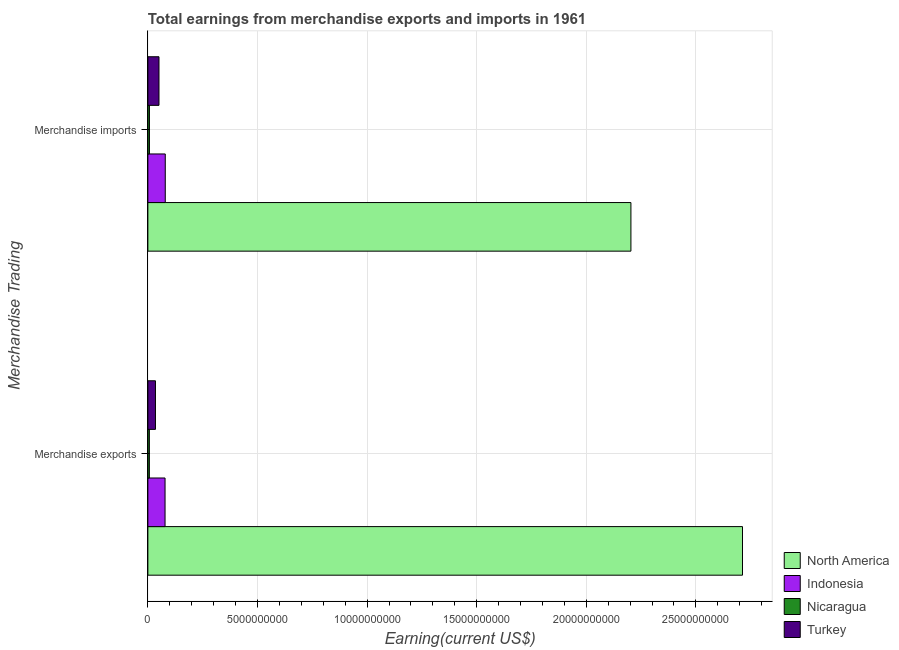How many groups of bars are there?
Ensure brevity in your answer.  2. Are the number of bars per tick equal to the number of legend labels?
Give a very brief answer. Yes. What is the label of the 2nd group of bars from the top?
Your answer should be very brief. Merchandise exports. What is the earnings from merchandise imports in Turkey?
Offer a very short reply. 5.07e+08. Across all countries, what is the maximum earnings from merchandise imports?
Provide a short and direct response. 2.20e+1. Across all countries, what is the minimum earnings from merchandise imports?
Provide a short and direct response. 7.15e+07. In which country was the earnings from merchandise exports maximum?
Offer a terse response. North America. In which country was the earnings from merchandise exports minimum?
Make the answer very short. Nicaragua. What is the total earnings from merchandise exports in the graph?
Give a very brief answer. 2.83e+1. What is the difference between the earnings from merchandise imports in North America and that in Turkey?
Offer a terse response. 2.15e+1. What is the difference between the earnings from merchandise imports in Nicaragua and the earnings from merchandise exports in Indonesia?
Provide a succinct answer. -7.13e+08. What is the average earnings from merchandise imports per country?
Give a very brief answer. 5.85e+09. What is the difference between the earnings from merchandise imports and earnings from merchandise exports in Turkey?
Provide a short and direct response. 1.60e+08. In how many countries, is the earnings from merchandise exports greater than 2000000000 US$?
Make the answer very short. 1. What is the ratio of the earnings from merchandise exports in Turkey to that in Indonesia?
Give a very brief answer. 0.44. Is the earnings from merchandise exports in Turkey less than that in Indonesia?
Keep it short and to the point. Yes. In how many countries, is the earnings from merchandise exports greater than the average earnings from merchandise exports taken over all countries?
Ensure brevity in your answer.  1. What does the 3rd bar from the top in Merchandise exports represents?
Your answer should be very brief. Indonesia. What does the 3rd bar from the bottom in Merchandise imports represents?
Your answer should be compact. Nicaragua. How many bars are there?
Keep it short and to the point. 8. Are all the bars in the graph horizontal?
Offer a very short reply. Yes. What is the difference between two consecutive major ticks on the X-axis?
Make the answer very short. 5.00e+09. Does the graph contain grids?
Your answer should be very brief. Yes. Where does the legend appear in the graph?
Offer a very short reply. Bottom right. What is the title of the graph?
Keep it short and to the point. Total earnings from merchandise exports and imports in 1961. Does "Oman" appear as one of the legend labels in the graph?
Offer a very short reply. No. What is the label or title of the X-axis?
Your answer should be very brief. Earning(current US$). What is the label or title of the Y-axis?
Your answer should be compact. Merchandise Trading. What is the Earning(current US$) of North America in Merchandise exports?
Offer a terse response. 2.71e+1. What is the Earning(current US$) in Indonesia in Merchandise exports?
Provide a short and direct response. 7.84e+08. What is the Earning(current US$) of Nicaragua in Merchandise exports?
Your response must be concise. 6.84e+07. What is the Earning(current US$) in Turkey in Merchandise exports?
Your answer should be very brief. 3.47e+08. What is the Earning(current US$) in North America in Merchandise imports?
Provide a succinct answer. 2.20e+1. What is the Earning(current US$) of Indonesia in Merchandise imports?
Offer a terse response. 7.94e+08. What is the Earning(current US$) of Nicaragua in Merchandise imports?
Your answer should be compact. 7.15e+07. What is the Earning(current US$) of Turkey in Merchandise imports?
Your response must be concise. 5.07e+08. Across all Merchandise Trading, what is the maximum Earning(current US$) of North America?
Offer a terse response. 2.71e+1. Across all Merchandise Trading, what is the maximum Earning(current US$) in Indonesia?
Provide a succinct answer. 7.94e+08. Across all Merchandise Trading, what is the maximum Earning(current US$) in Nicaragua?
Provide a short and direct response. 7.15e+07. Across all Merchandise Trading, what is the maximum Earning(current US$) of Turkey?
Keep it short and to the point. 5.07e+08. Across all Merchandise Trading, what is the minimum Earning(current US$) of North America?
Your answer should be very brief. 2.20e+1. Across all Merchandise Trading, what is the minimum Earning(current US$) of Indonesia?
Provide a succinct answer. 7.84e+08. Across all Merchandise Trading, what is the minimum Earning(current US$) in Nicaragua?
Offer a terse response. 6.84e+07. Across all Merchandise Trading, what is the minimum Earning(current US$) in Turkey?
Your answer should be compact. 3.47e+08. What is the total Earning(current US$) in North America in the graph?
Ensure brevity in your answer.  4.92e+1. What is the total Earning(current US$) of Indonesia in the graph?
Provide a short and direct response. 1.58e+09. What is the total Earning(current US$) in Nicaragua in the graph?
Make the answer very short. 1.40e+08. What is the total Earning(current US$) of Turkey in the graph?
Give a very brief answer. 8.54e+08. What is the difference between the Earning(current US$) of North America in Merchandise exports and that in Merchandise imports?
Provide a short and direct response. 5.09e+09. What is the difference between the Earning(current US$) of Indonesia in Merchandise exports and that in Merchandise imports?
Your answer should be compact. -1.00e+07. What is the difference between the Earning(current US$) in Nicaragua in Merchandise exports and that in Merchandise imports?
Your answer should be compact. -3.11e+06. What is the difference between the Earning(current US$) in Turkey in Merchandise exports and that in Merchandise imports?
Ensure brevity in your answer.  -1.60e+08. What is the difference between the Earning(current US$) of North America in Merchandise exports and the Earning(current US$) of Indonesia in Merchandise imports?
Keep it short and to the point. 2.63e+1. What is the difference between the Earning(current US$) in North America in Merchandise exports and the Earning(current US$) in Nicaragua in Merchandise imports?
Offer a terse response. 2.71e+1. What is the difference between the Earning(current US$) of North America in Merchandise exports and the Earning(current US$) of Turkey in Merchandise imports?
Your answer should be compact. 2.66e+1. What is the difference between the Earning(current US$) of Indonesia in Merchandise exports and the Earning(current US$) of Nicaragua in Merchandise imports?
Provide a short and direct response. 7.13e+08. What is the difference between the Earning(current US$) in Indonesia in Merchandise exports and the Earning(current US$) in Turkey in Merchandise imports?
Your answer should be compact. 2.77e+08. What is the difference between the Earning(current US$) in Nicaragua in Merchandise exports and the Earning(current US$) in Turkey in Merchandise imports?
Your response must be concise. -4.39e+08. What is the average Earning(current US$) of North America per Merchandise Trading?
Offer a terse response. 2.46e+1. What is the average Earning(current US$) in Indonesia per Merchandise Trading?
Keep it short and to the point. 7.89e+08. What is the average Earning(current US$) of Nicaragua per Merchandise Trading?
Offer a very short reply. 6.99e+07. What is the average Earning(current US$) of Turkey per Merchandise Trading?
Give a very brief answer. 4.27e+08. What is the difference between the Earning(current US$) in North America and Earning(current US$) in Indonesia in Merchandise exports?
Ensure brevity in your answer.  2.63e+1. What is the difference between the Earning(current US$) of North America and Earning(current US$) of Nicaragua in Merchandise exports?
Your answer should be very brief. 2.71e+1. What is the difference between the Earning(current US$) of North America and Earning(current US$) of Turkey in Merchandise exports?
Provide a succinct answer. 2.68e+1. What is the difference between the Earning(current US$) in Indonesia and Earning(current US$) in Nicaragua in Merchandise exports?
Provide a succinct answer. 7.16e+08. What is the difference between the Earning(current US$) in Indonesia and Earning(current US$) in Turkey in Merchandise exports?
Offer a very short reply. 4.37e+08. What is the difference between the Earning(current US$) in Nicaragua and Earning(current US$) in Turkey in Merchandise exports?
Give a very brief answer. -2.78e+08. What is the difference between the Earning(current US$) in North America and Earning(current US$) in Indonesia in Merchandise imports?
Your answer should be compact. 2.12e+1. What is the difference between the Earning(current US$) of North America and Earning(current US$) of Nicaragua in Merchandise imports?
Offer a terse response. 2.20e+1. What is the difference between the Earning(current US$) of North America and Earning(current US$) of Turkey in Merchandise imports?
Your answer should be compact. 2.15e+1. What is the difference between the Earning(current US$) in Indonesia and Earning(current US$) in Nicaragua in Merchandise imports?
Offer a very short reply. 7.23e+08. What is the difference between the Earning(current US$) of Indonesia and Earning(current US$) of Turkey in Merchandise imports?
Your response must be concise. 2.87e+08. What is the difference between the Earning(current US$) in Nicaragua and Earning(current US$) in Turkey in Merchandise imports?
Give a very brief answer. -4.36e+08. What is the ratio of the Earning(current US$) in North America in Merchandise exports to that in Merchandise imports?
Your answer should be very brief. 1.23. What is the ratio of the Earning(current US$) in Indonesia in Merchandise exports to that in Merchandise imports?
Your answer should be compact. 0.99. What is the ratio of the Earning(current US$) of Nicaragua in Merchandise exports to that in Merchandise imports?
Your response must be concise. 0.96. What is the ratio of the Earning(current US$) in Turkey in Merchandise exports to that in Merchandise imports?
Keep it short and to the point. 0.68. What is the difference between the highest and the second highest Earning(current US$) in North America?
Make the answer very short. 5.09e+09. What is the difference between the highest and the second highest Earning(current US$) of Nicaragua?
Your answer should be compact. 3.11e+06. What is the difference between the highest and the second highest Earning(current US$) of Turkey?
Provide a short and direct response. 1.60e+08. What is the difference between the highest and the lowest Earning(current US$) in North America?
Ensure brevity in your answer.  5.09e+09. What is the difference between the highest and the lowest Earning(current US$) in Nicaragua?
Your response must be concise. 3.11e+06. What is the difference between the highest and the lowest Earning(current US$) in Turkey?
Give a very brief answer. 1.60e+08. 